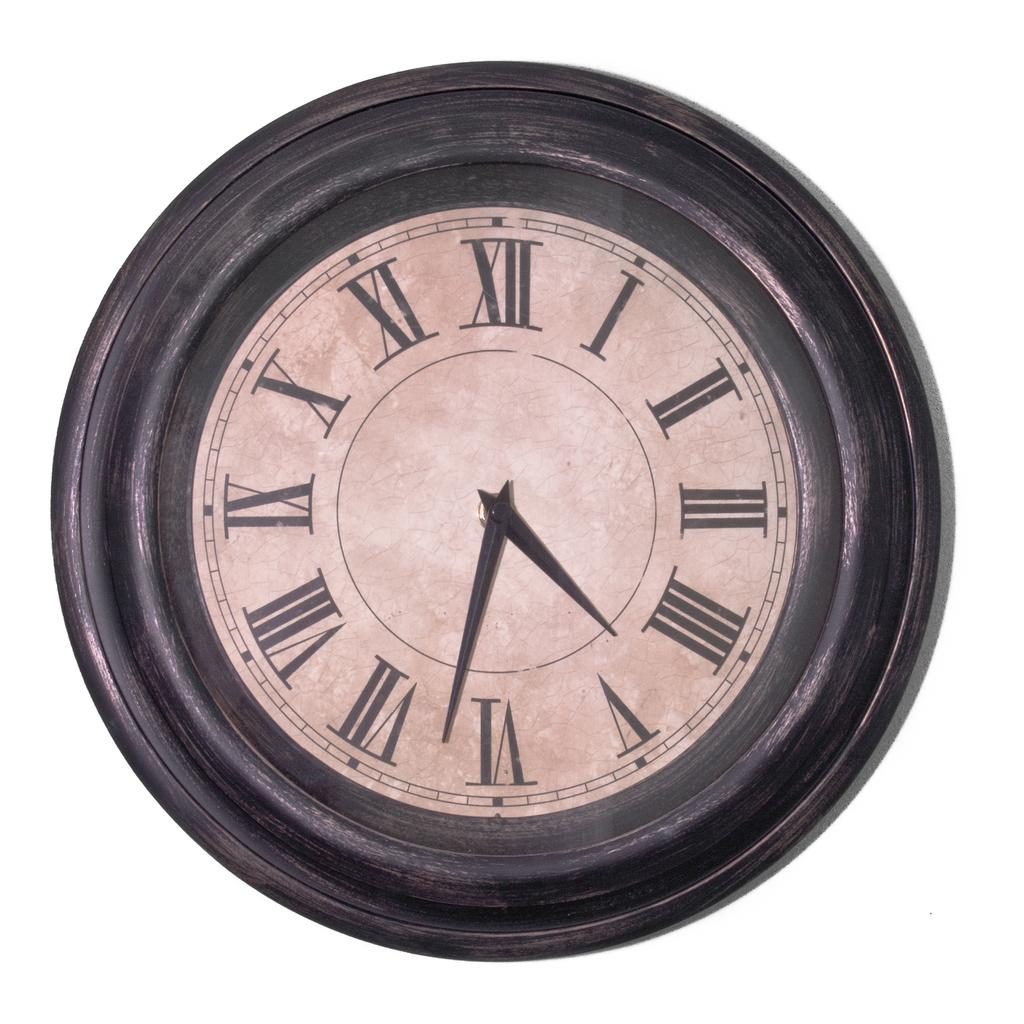Provide a one-sentence caption for the provided image. A clock with roman numerals on it shows the time as 4:32. 